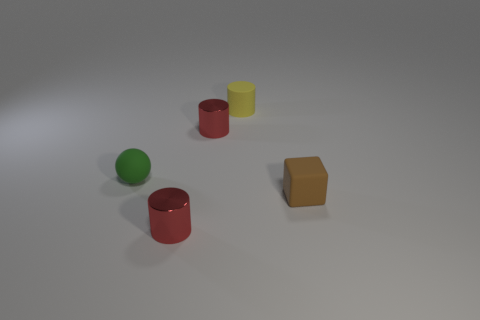Subtract all small red cylinders. How many cylinders are left? 1 Add 3 large red metal balls. How many objects exist? 8 Subtract all brown balls. How many red cylinders are left? 2 Subtract all yellow cylinders. How many cylinders are left? 2 Subtract 2 cylinders. How many cylinders are left? 1 Subtract 0 purple balls. How many objects are left? 5 Subtract all spheres. How many objects are left? 4 Subtract all gray balls. Subtract all purple cubes. How many balls are left? 1 Subtract all balls. Subtract all rubber cubes. How many objects are left? 3 Add 5 small red cylinders. How many small red cylinders are left? 7 